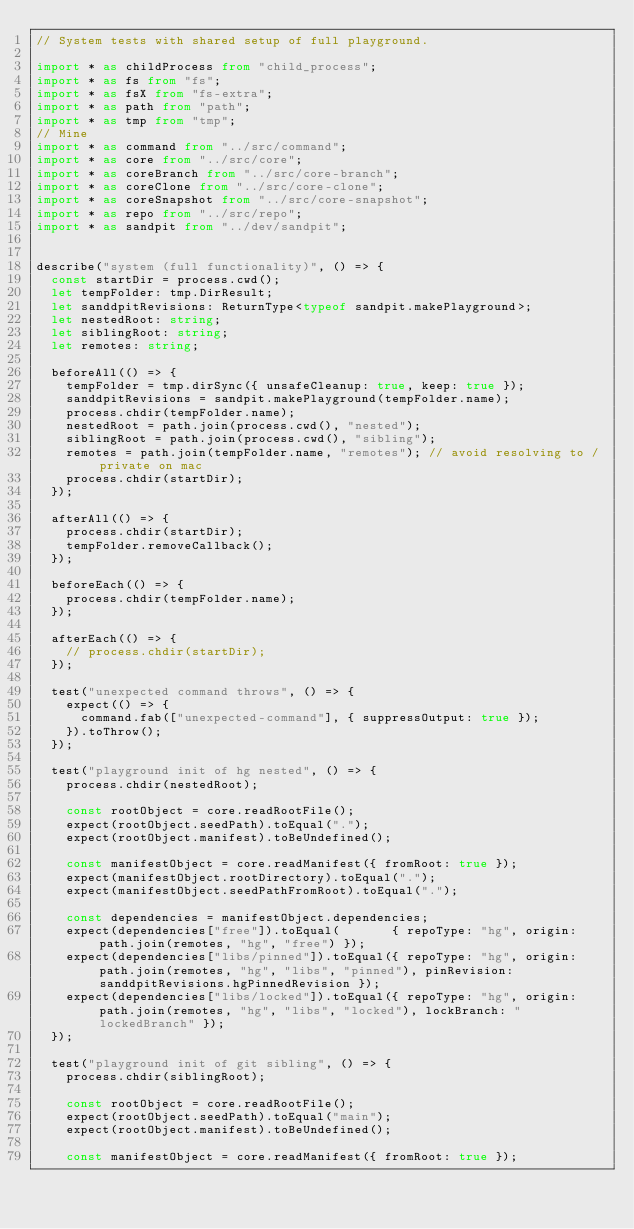Convert code to text. <code><loc_0><loc_0><loc_500><loc_500><_TypeScript_>// System tests with shared setup of full playground.

import * as childProcess from "child_process";
import * as fs from "fs";
import * as fsX from "fs-extra";
import * as path from "path";
import * as tmp from "tmp";
// Mine
import * as command from "../src/command";
import * as core from "../src/core";
import * as coreBranch from "../src/core-branch";
import * as coreClone from "../src/core-clone";
import * as coreSnapshot from "../src/core-snapshot";
import * as repo from "../src/repo";
import * as sandpit from "../dev/sandpit";


describe("system (full functionality)", () => {
  const startDir = process.cwd();
  let tempFolder: tmp.DirResult;
  let sanddpitRevisions: ReturnType<typeof sandpit.makePlayground>;
  let nestedRoot: string;
  let siblingRoot: string;
  let remotes: string;

  beforeAll(() => {
    tempFolder = tmp.dirSync({ unsafeCleanup: true, keep: true });
    sanddpitRevisions = sandpit.makePlayground(tempFolder.name);
    process.chdir(tempFolder.name);
    nestedRoot = path.join(process.cwd(), "nested");
    siblingRoot = path.join(process.cwd(), "sibling");
    remotes = path.join(tempFolder.name, "remotes"); // avoid resolving to /private on mac
    process.chdir(startDir);
  });

  afterAll(() => {
    process.chdir(startDir);
    tempFolder.removeCallback();
  });

  beforeEach(() => {
    process.chdir(tempFolder.name);
  });

  afterEach(() => {
    // process.chdir(startDir);
  });

  test("unexpected command throws", () => {
    expect(() => {
      command.fab(["unexpected-command"], { suppressOutput: true });
    }).toThrow();
  });

  test("playground init of hg nested", () => {
    process.chdir(nestedRoot);

    const rootObject = core.readRootFile();
    expect(rootObject.seedPath).toEqual(".");
    expect(rootObject.manifest).toBeUndefined();

    const manifestObject = core.readManifest({ fromRoot: true });
    expect(manifestObject.rootDirectory).toEqual(".");
    expect(manifestObject.seedPathFromRoot).toEqual(".");

    const dependencies = manifestObject.dependencies;
    expect(dependencies["free"]).toEqual(       { repoType: "hg", origin: path.join(remotes, "hg", "free") });
    expect(dependencies["libs/pinned"]).toEqual({ repoType: "hg", origin: path.join(remotes, "hg", "libs", "pinned"), pinRevision: sanddpitRevisions.hgPinnedRevision });
    expect(dependencies["libs/locked"]).toEqual({ repoType: "hg", origin: path.join(remotes, "hg", "libs", "locked"), lockBranch: "lockedBranch" });
  });

  test("playground init of git sibling", () => {
    process.chdir(siblingRoot);

    const rootObject = core.readRootFile();
    expect(rootObject.seedPath).toEqual("main");
    expect(rootObject.manifest).toBeUndefined();

    const manifestObject = core.readManifest({ fromRoot: true });</code> 